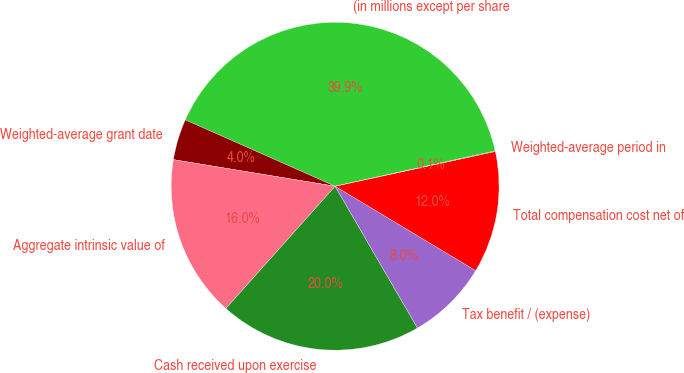<chart> <loc_0><loc_0><loc_500><loc_500><pie_chart><fcel>(in millions except per share<fcel>Weighted-average grant date<fcel>Aggregate intrinsic value of<fcel>Cash received upon exercise<fcel>Tax benefit / (expense)<fcel>Total compensation cost net of<fcel>Weighted-average period in<nl><fcel>39.9%<fcel>4.04%<fcel>15.99%<fcel>19.98%<fcel>8.02%<fcel>12.01%<fcel>0.06%<nl></chart> 